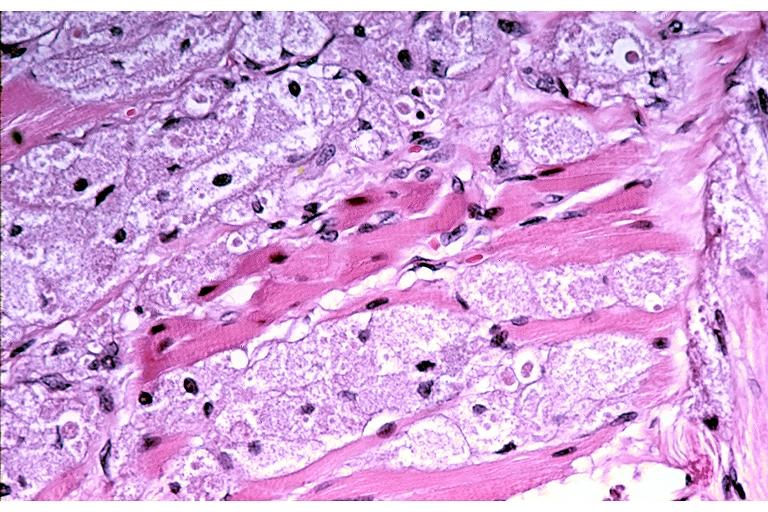what is present?
Answer the question using a single word or phrase. Oral 